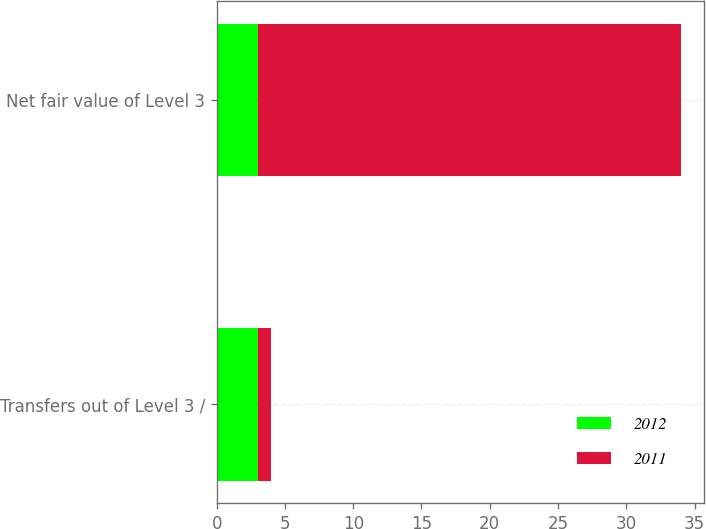Convert chart to OTSL. <chart><loc_0><loc_0><loc_500><loc_500><stacked_bar_chart><ecel><fcel>Transfers out of Level 3 /<fcel>Net fair value of Level 3<nl><fcel>2012<fcel>3<fcel>3<nl><fcel>2011<fcel>1<fcel>31<nl></chart> 